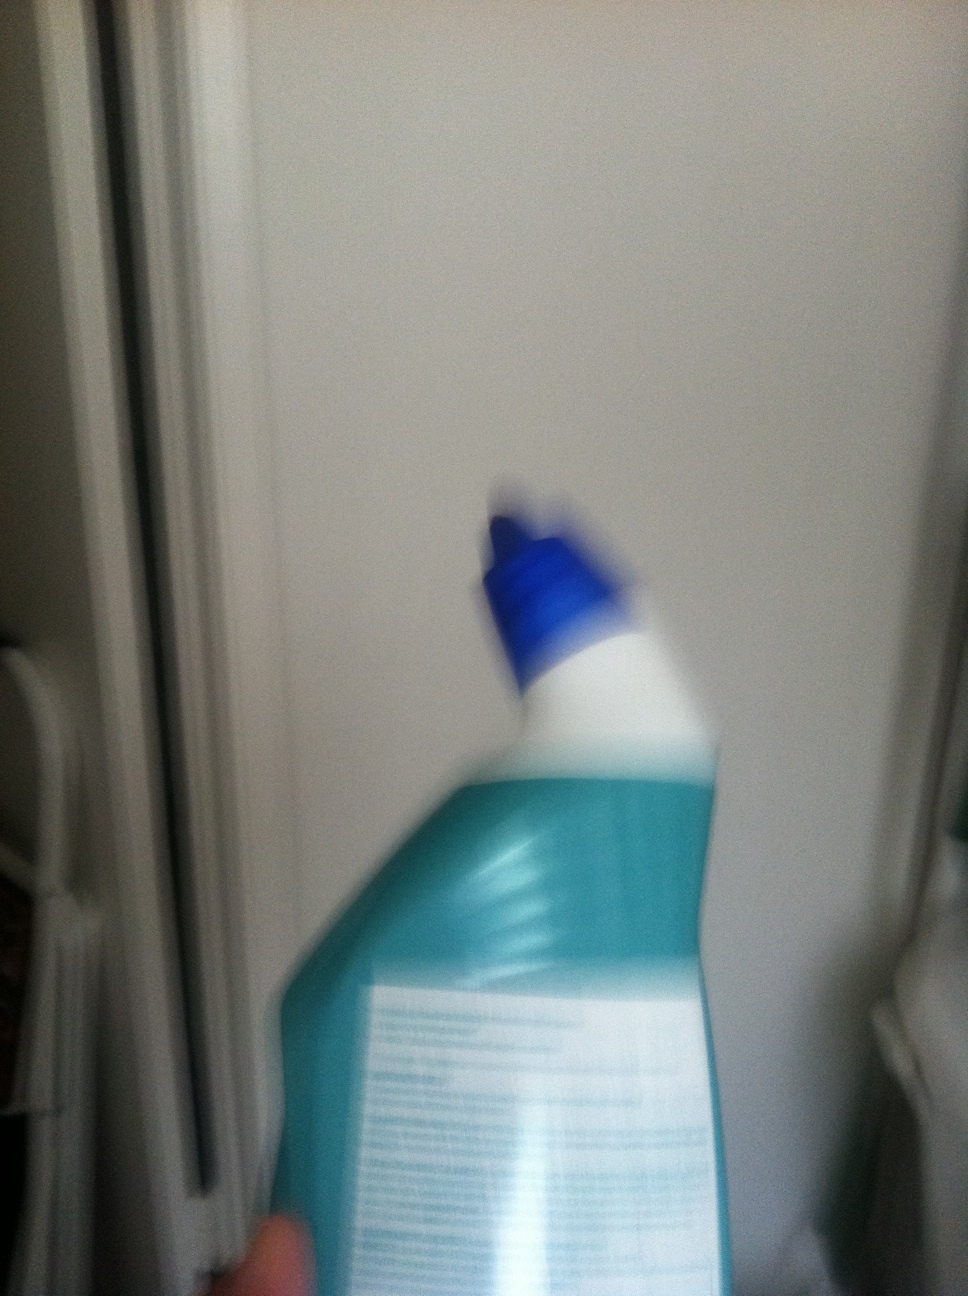What is this? The image is not clear, which makes it challenging to identify with certainty. However, it appears to be a bottle, possibly containing a cleaning product, based on its shape and the visible cap. 